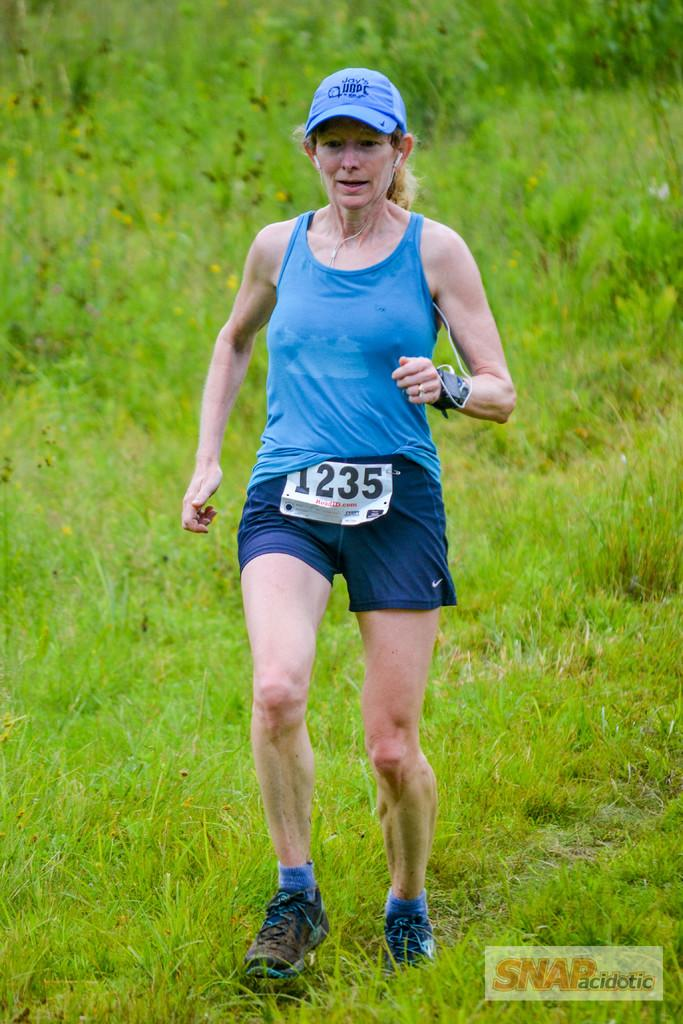<image>
Describe the image concisely. Runner number 1235 is a female wearing a blue hat, tank top, and shorts. 